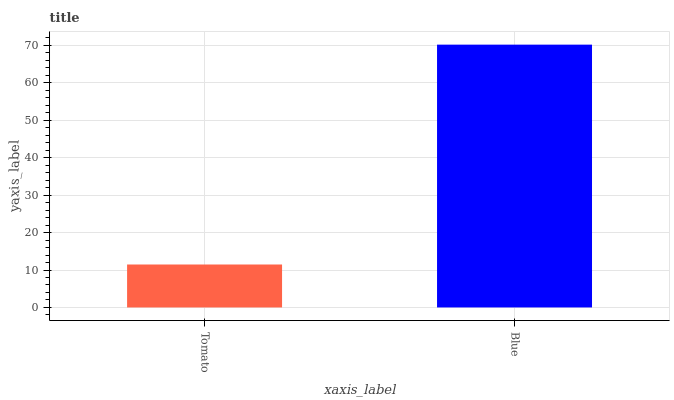Is Tomato the minimum?
Answer yes or no. Yes. Is Blue the maximum?
Answer yes or no. Yes. Is Blue the minimum?
Answer yes or no. No. Is Blue greater than Tomato?
Answer yes or no. Yes. Is Tomato less than Blue?
Answer yes or no. Yes. Is Tomato greater than Blue?
Answer yes or no. No. Is Blue less than Tomato?
Answer yes or no. No. Is Blue the high median?
Answer yes or no. Yes. Is Tomato the low median?
Answer yes or no. Yes. Is Tomato the high median?
Answer yes or no. No. Is Blue the low median?
Answer yes or no. No. 